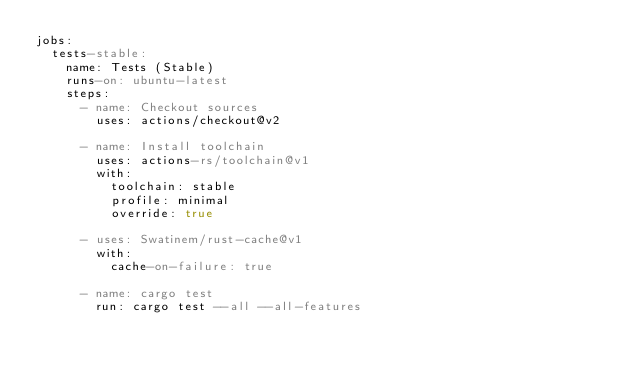<code> <loc_0><loc_0><loc_500><loc_500><_YAML_>jobs:
  tests-stable:
    name: Tests (Stable)
    runs-on: ubuntu-latest
    steps:
      - name: Checkout sources
        uses: actions/checkout@v2

      - name: Install toolchain
        uses: actions-rs/toolchain@v1
        with:
          toolchain: stable
          profile: minimal
          override: true

      - uses: Swatinem/rust-cache@v1
        with:
          cache-on-failure: true

      - name: cargo test
        run: cargo test --all --all-features</code> 